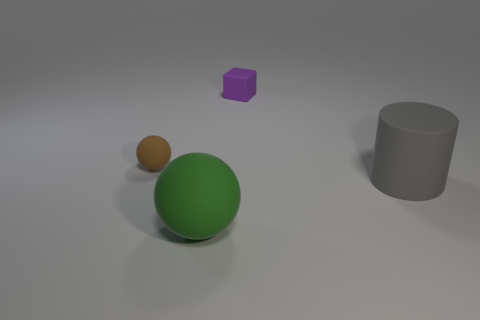Add 4 cyan matte cylinders. How many objects exist? 8 Subtract all cubes. How many objects are left? 3 Subtract all large cyan shiny cubes. Subtract all gray rubber things. How many objects are left? 3 Add 4 small brown matte objects. How many small brown matte objects are left? 5 Add 2 big cyan blocks. How many big cyan blocks exist? 2 Subtract 1 brown spheres. How many objects are left? 3 